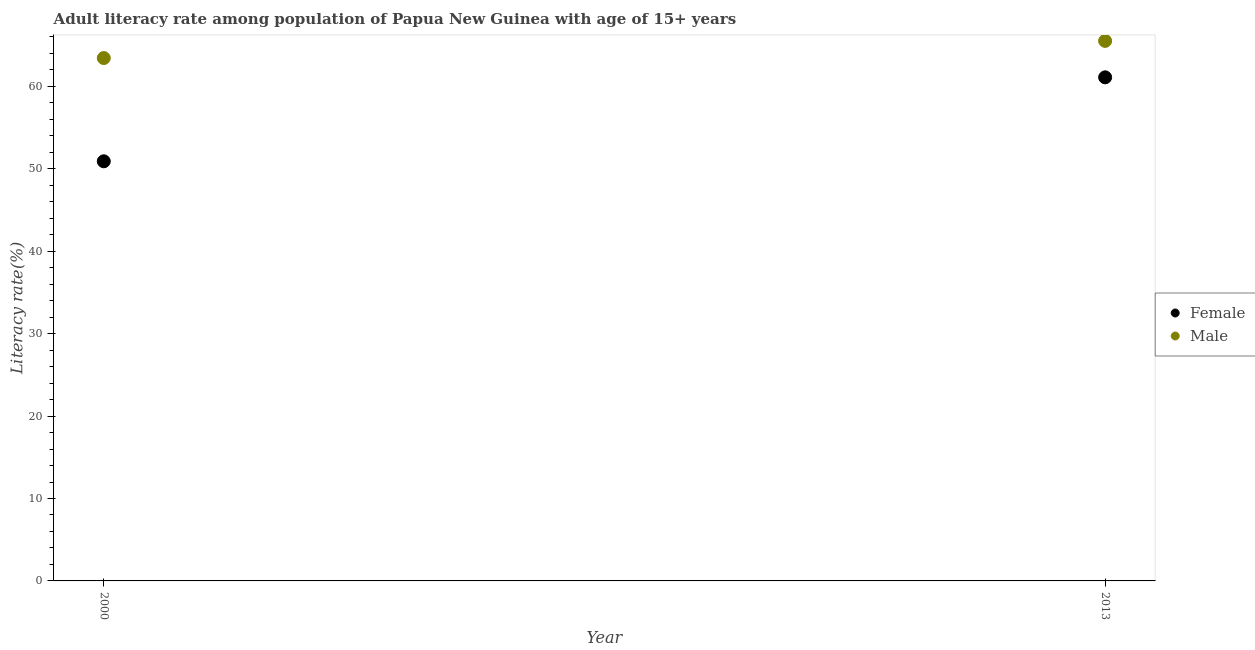What is the male adult literacy rate in 2000?
Ensure brevity in your answer.  63.45. Across all years, what is the maximum female adult literacy rate?
Provide a short and direct response. 61.1. Across all years, what is the minimum female adult literacy rate?
Provide a succinct answer. 50.92. In which year was the male adult literacy rate maximum?
Ensure brevity in your answer.  2013. What is the total female adult literacy rate in the graph?
Provide a short and direct response. 112.02. What is the difference between the female adult literacy rate in 2000 and that in 2013?
Your answer should be compact. -10.19. What is the difference between the female adult literacy rate in 2013 and the male adult literacy rate in 2000?
Give a very brief answer. -2.34. What is the average female adult literacy rate per year?
Offer a terse response. 56.01. In the year 2000, what is the difference between the male adult literacy rate and female adult literacy rate?
Provide a short and direct response. 12.53. What is the ratio of the female adult literacy rate in 2000 to that in 2013?
Ensure brevity in your answer.  0.83. Is the male adult literacy rate in 2000 less than that in 2013?
Make the answer very short. Yes. In how many years, is the male adult literacy rate greater than the average male adult literacy rate taken over all years?
Provide a short and direct response. 1. Does the female adult literacy rate monotonically increase over the years?
Your answer should be compact. Yes. Is the male adult literacy rate strictly greater than the female adult literacy rate over the years?
Provide a short and direct response. Yes. Is the male adult literacy rate strictly less than the female adult literacy rate over the years?
Offer a terse response. No. How many dotlines are there?
Provide a short and direct response. 2. How many years are there in the graph?
Offer a very short reply. 2. Are the values on the major ticks of Y-axis written in scientific E-notation?
Your response must be concise. No. Where does the legend appear in the graph?
Give a very brief answer. Center right. How many legend labels are there?
Give a very brief answer. 2. What is the title of the graph?
Give a very brief answer. Adult literacy rate among population of Papua New Guinea with age of 15+ years. What is the label or title of the Y-axis?
Offer a terse response. Literacy rate(%). What is the Literacy rate(%) in Female in 2000?
Make the answer very short. 50.92. What is the Literacy rate(%) of Male in 2000?
Provide a succinct answer. 63.45. What is the Literacy rate(%) in Female in 2013?
Keep it short and to the point. 61.1. What is the Literacy rate(%) of Male in 2013?
Provide a succinct answer. 65.53. Across all years, what is the maximum Literacy rate(%) of Female?
Make the answer very short. 61.1. Across all years, what is the maximum Literacy rate(%) of Male?
Offer a terse response. 65.53. Across all years, what is the minimum Literacy rate(%) of Female?
Provide a short and direct response. 50.92. Across all years, what is the minimum Literacy rate(%) of Male?
Provide a succinct answer. 63.45. What is the total Literacy rate(%) of Female in the graph?
Offer a terse response. 112.02. What is the total Literacy rate(%) in Male in the graph?
Provide a short and direct response. 128.97. What is the difference between the Literacy rate(%) of Female in 2000 and that in 2013?
Offer a very short reply. -10.19. What is the difference between the Literacy rate(%) in Male in 2000 and that in 2013?
Offer a terse response. -2.08. What is the difference between the Literacy rate(%) in Female in 2000 and the Literacy rate(%) in Male in 2013?
Your answer should be very brief. -14.61. What is the average Literacy rate(%) of Female per year?
Your response must be concise. 56.01. What is the average Literacy rate(%) of Male per year?
Your answer should be very brief. 64.49. In the year 2000, what is the difference between the Literacy rate(%) of Female and Literacy rate(%) of Male?
Ensure brevity in your answer.  -12.53. In the year 2013, what is the difference between the Literacy rate(%) in Female and Literacy rate(%) in Male?
Offer a very short reply. -4.42. What is the ratio of the Literacy rate(%) of Female in 2000 to that in 2013?
Your answer should be very brief. 0.83. What is the ratio of the Literacy rate(%) in Male in 2000 to that in 2013?
Your answer should be compact. 0.97. What is the difference between the highest and the second highest Literacy rate(%) in Female?
Ensure brevity in your answer.  10.19. What is the difference between the highest and the second highest Literacy rate(%) in Male?
Your answer should be very brief. 2.08. What is the difference between the highest and the lowest Literacy rate(%) of Female?
Offer a terse response. 10.19. What is the difference between the highest and the lowest Literacy rate(%) in Male?
Your answer should be very brief. 2.08. 